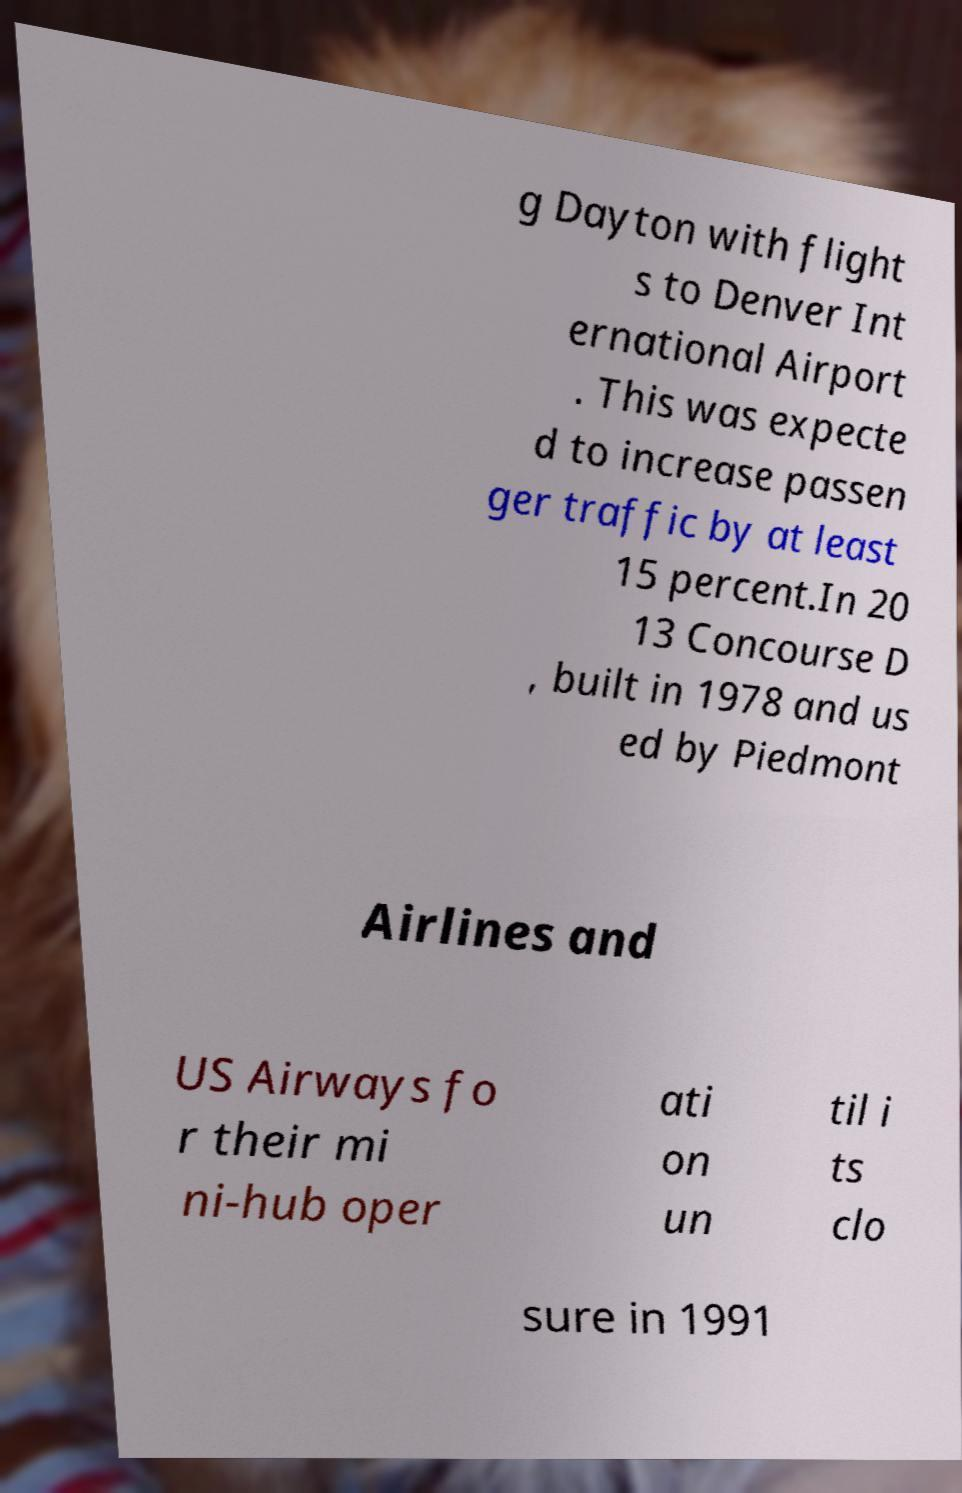Can you accurately transcribe the text from the provided image for me? g Dayton with flight s to Denver Int ernational Airport . This was expecte d to increase passen ger traffic by at least 15 percent.In 20 13 Concourse D , built in 1978 and us ed by Piedmont Airlines and US Airways fo r their mi ni-hub oper ati on un til i ts clo sure in 1991 